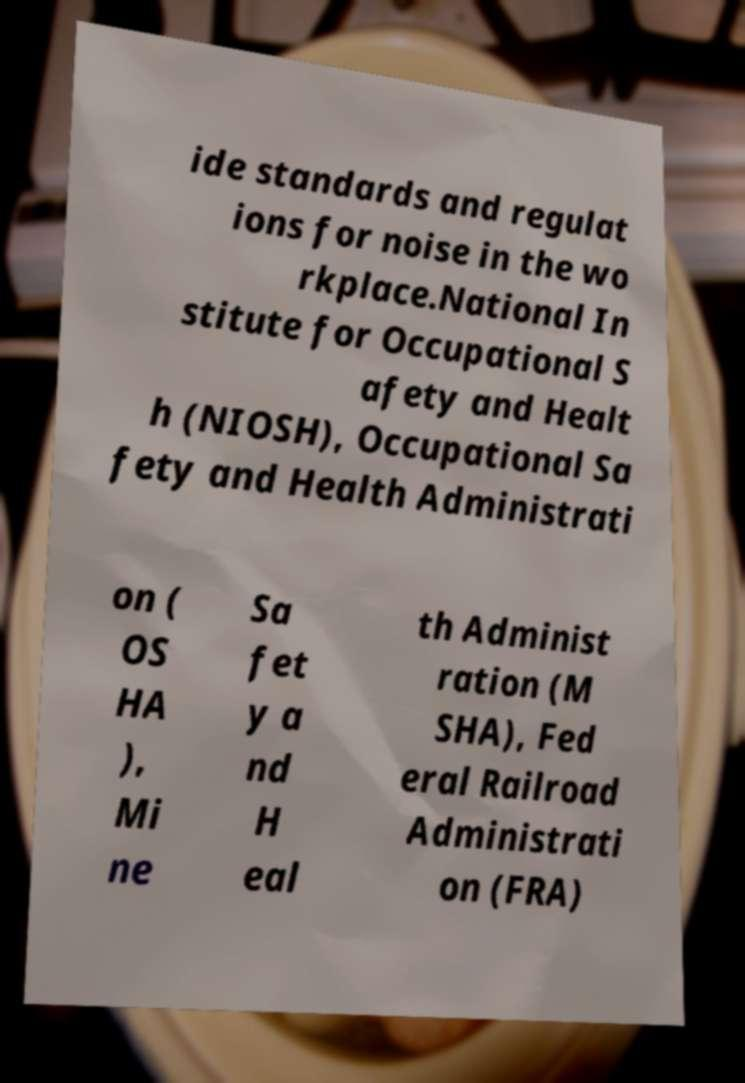Could you assist in decoding the text presented in this image and type it out clearly? ide standards and regulat ions for noise in the wo rkplace.National In stitute for Occupational S afety and Healt h (NIOSH), Occupational Sa fety and Health Administrati on ( OS HA ), Mi ne Sa fet y a nd H eal th Administ ration (M SHA), Fed eral Railroad Administrati on (FRA) 